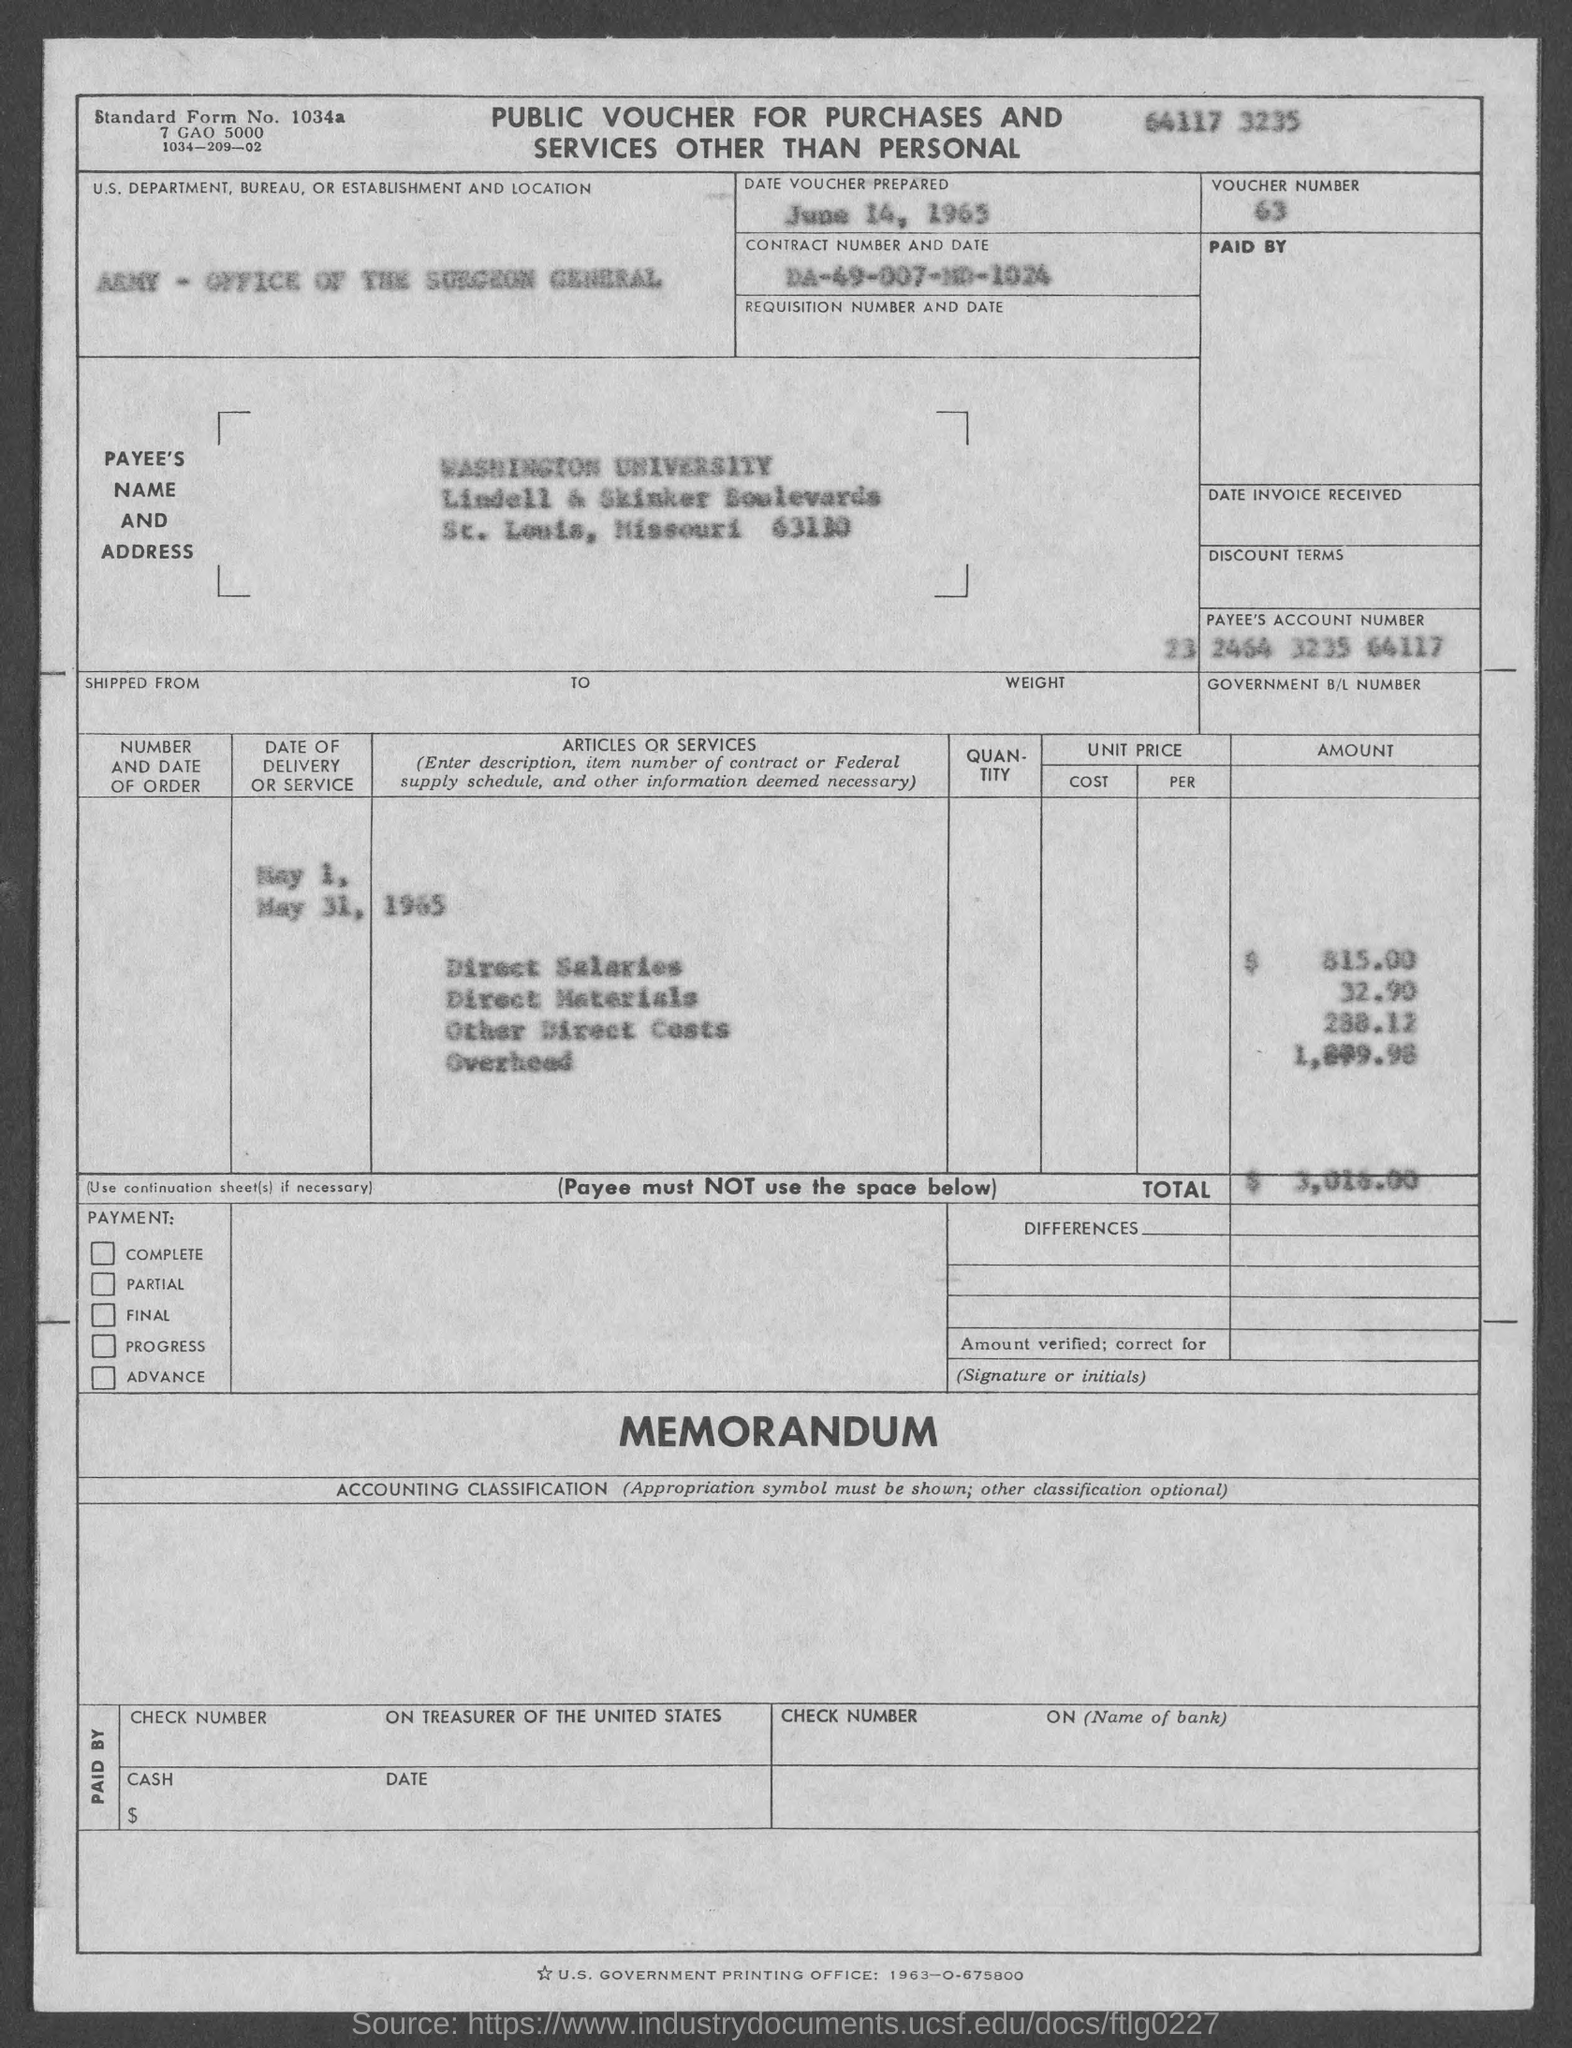Point out several critical features in this image. The voucher number is 63. The date voucher was prepared on June 14, 1965. The United States Department, Bureau, or Establishment that appears in the voucher is the Army - Office of the Surgeon General. What is the standard form number? 